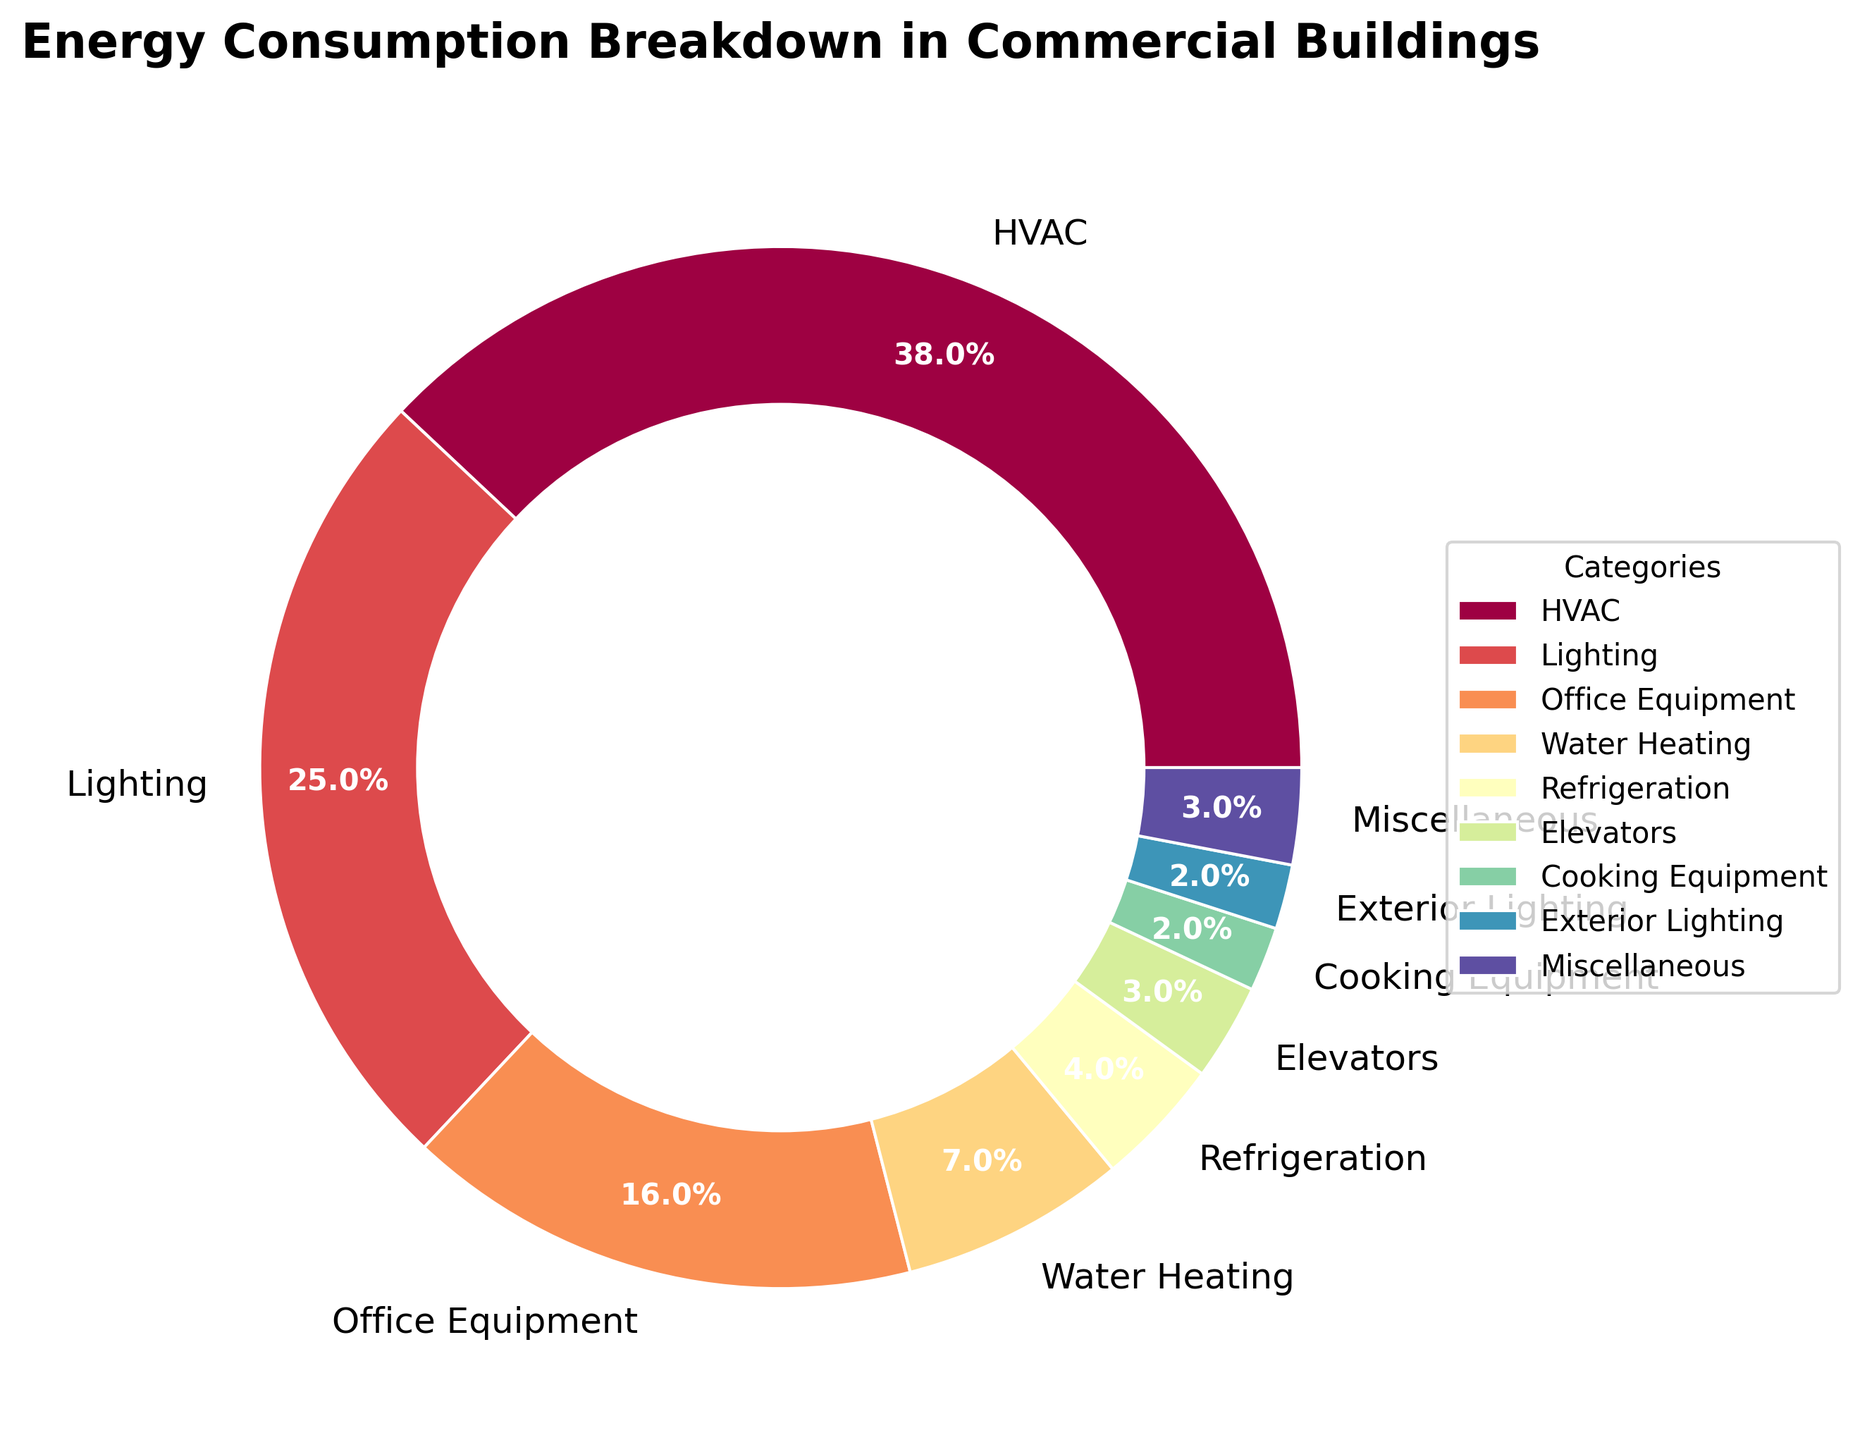What percentage of energy consumption is attributed to HVAC compared to lighting? According to the pie chart, the energy consumption for HVAC is 38% and for lighting is 25%. To compare, we look at the numerical difference: 38% - 25% = 13%. Therefore, HVAC consumes 13% more energy than lighting.
Answer: 13% What is the total percentage of energy consumption for office equipment and refrigeration combined? The energy consumption percentages for office equipment and refrigeration are 16% and 4%, respectively. Adding them together gives 16% + 4% = 20%.
Answer: 20% Which category has the second-highest energy consumption? From the pie chart, the highest energy consumption is attributed to HVAC at 38%. The next highest is lighting at 25%. Therefore, lighting is the second-highest category.
Answer: Lighting How much more energy does HVAC consume compared to water heating? HVAC accounts for 38% of energy consumption, whereas water heating accounts for 7%. To find the difference, we subtract the two percentages: 38% - 7% = 31%. Thus, HVAC consumes 31% more energy than water heating.
Answer: 31% What is the total percentage of energy consumption that goes into elevators, cooking equipment, and exterior lighting? The percentages for elevators, cooking equipment, and exterior lighting are 3%, 2%, and 2%, respectively. Adding them together gives 3% + 2% + 2% = 7%.
Answer: 7% What color represents the miscellaneous category? In the pie chart, the color representing the miscellaneous category should be noted from the corresponding labeled segment visually associated with the text "Miscellaneous". As this is dependent on the color scheme, we would refer to the given colors. From typical pie chart visualizations such as Spectral color maps used, a possible color can be inferred from visual observation. However, for accuracy, referring directly to the labeled segment in the pie chart is necessary.
Answer: Refer to visual How much more energy does office equipment consume compared to exterior lighting? Office equipment consumes 16% of the energy, whereas exterior lighting consumes 2%. The difference is calculated as 16% - 2% = 14%. Therefore, office equipment consumes 14% more energy than exterior lighting.
Answer: 14% What is the combined percentage of energy consumption for HVAC, lighting, and office equipment? Adding the individual percentages for HVAC (38%), lighting (25%), and office equipment (16%) gives a total of 38% + 25% + 16% = 79%.
Answer: 79% Which category has the smallest energy consumption and what is its percentage? In the pie chart, the category with the smallest energy consumption is cooking equipment at 2%.
Answer: Cooking Equipment, 2% If we were to reduce the energy consumption of HVAC by half, what would be its new percentage? The current energy consumption of HVAC is 38%. Reducing this by half (38% / 2 = 19%), the new energy consumption percentage for HVAC would be 19%.
Answer: 19% 